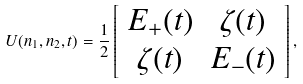<formula> <loc_0><loc_0><loc_500><loc_500>U ( n _ { 1 } , n _ { 2 } , t ) = \frac { 1 } { 2 } \left [ \begin{array} { c c } E _ { + } ( t ) & \zeta ( t ) \\ \zeta ( t ) & E _ { - } ( t ) \end{array} \right ] ,</formula> 